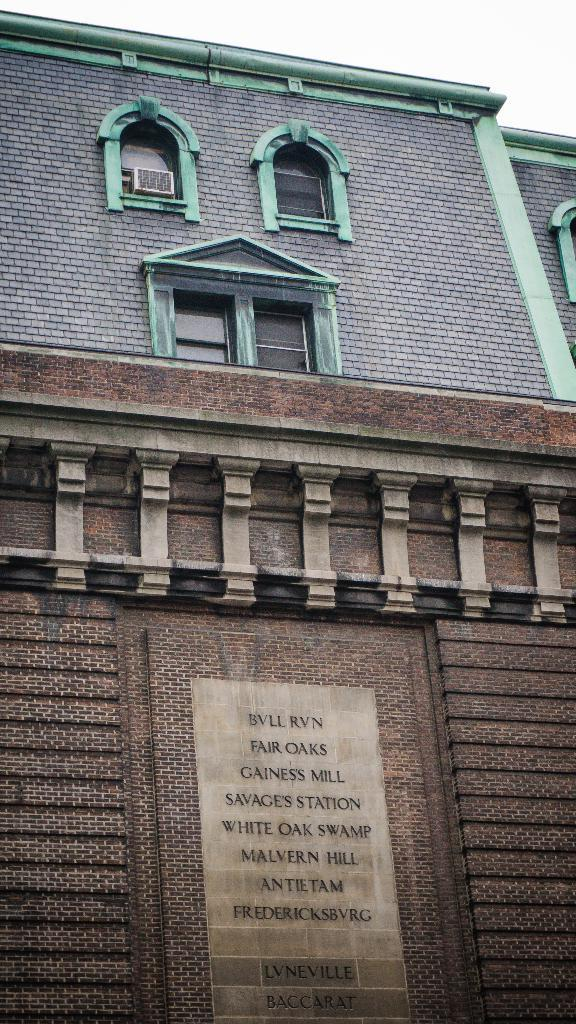What type of structure is visible in the image? There is a building in the image. What are the main features of the building? The building has walls and windows. Is there any equipment visible on the building? Yes, there is an air conditioner on the building. What can be seen on the walls of the building? There are names written on the wall and designs on the wall. Can you see any veins in the image? There are no veins visible in the image; it features a building with walls, windows, and designs. What type of verse can be seen written on the wall? There is no verse written on the wall in the image; only names and designs are present. 